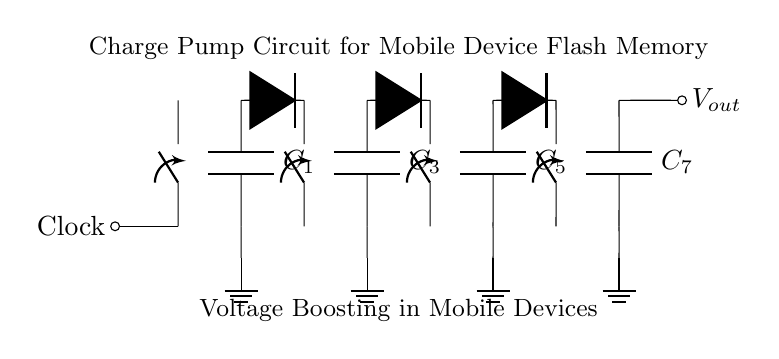What type of circuit is this? This circuit is a charge pump circuit, which converts a lower voltage to a higher voltage by using capacitors and switches to boost the voltage output.
Answer: Charge pump circuit How many capacitors are present in the circuit? There are four capacitors labeled C1, C2, C3, and C4, as indicated by the four capacitor symbols in the circuit.
Answer: Four What is the purpose of the diodes in this circuit? The diodes are used to allow current to flow in one direction while blocking it in the opposite direction, which is essential for the proper functioning of the charge pump circuit to ensure voltage boosting.
Answer: Allow current in one direction What is the voltage output of this circuit? While the circuit diagram does not specify the exact voltage, charge pump circuits typically output a voltage greater than the input clock voltage, typically in mobile devices to enhance performance.
Answer: Greater than input voltage Why is a clock signal used in this charge pump circuit? The clock signal provides the timing needed to control the switches in the circuit, allowing the capacitors to charge and discharge in a synchronized manner, which is necessary for effective voltage boosting.
Answer: Timing control 